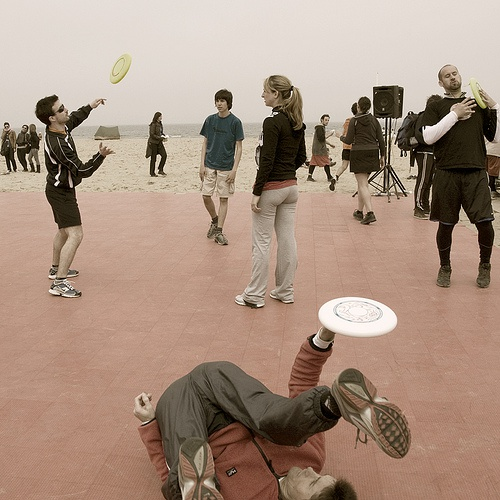Describe the objects in this image and their specific colors. I can see people in lightgray, maroon, gray, and black tones, people in lightgray, black, gray, and tan tones, people in lightgray, black, darkgray, and gray tones, people in lightgray, black, gray, and tan tones, and people in lightgray, black, and tan tones in this image. 